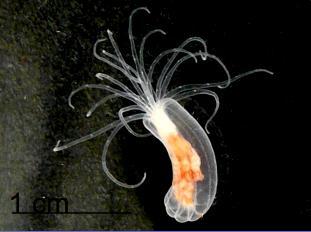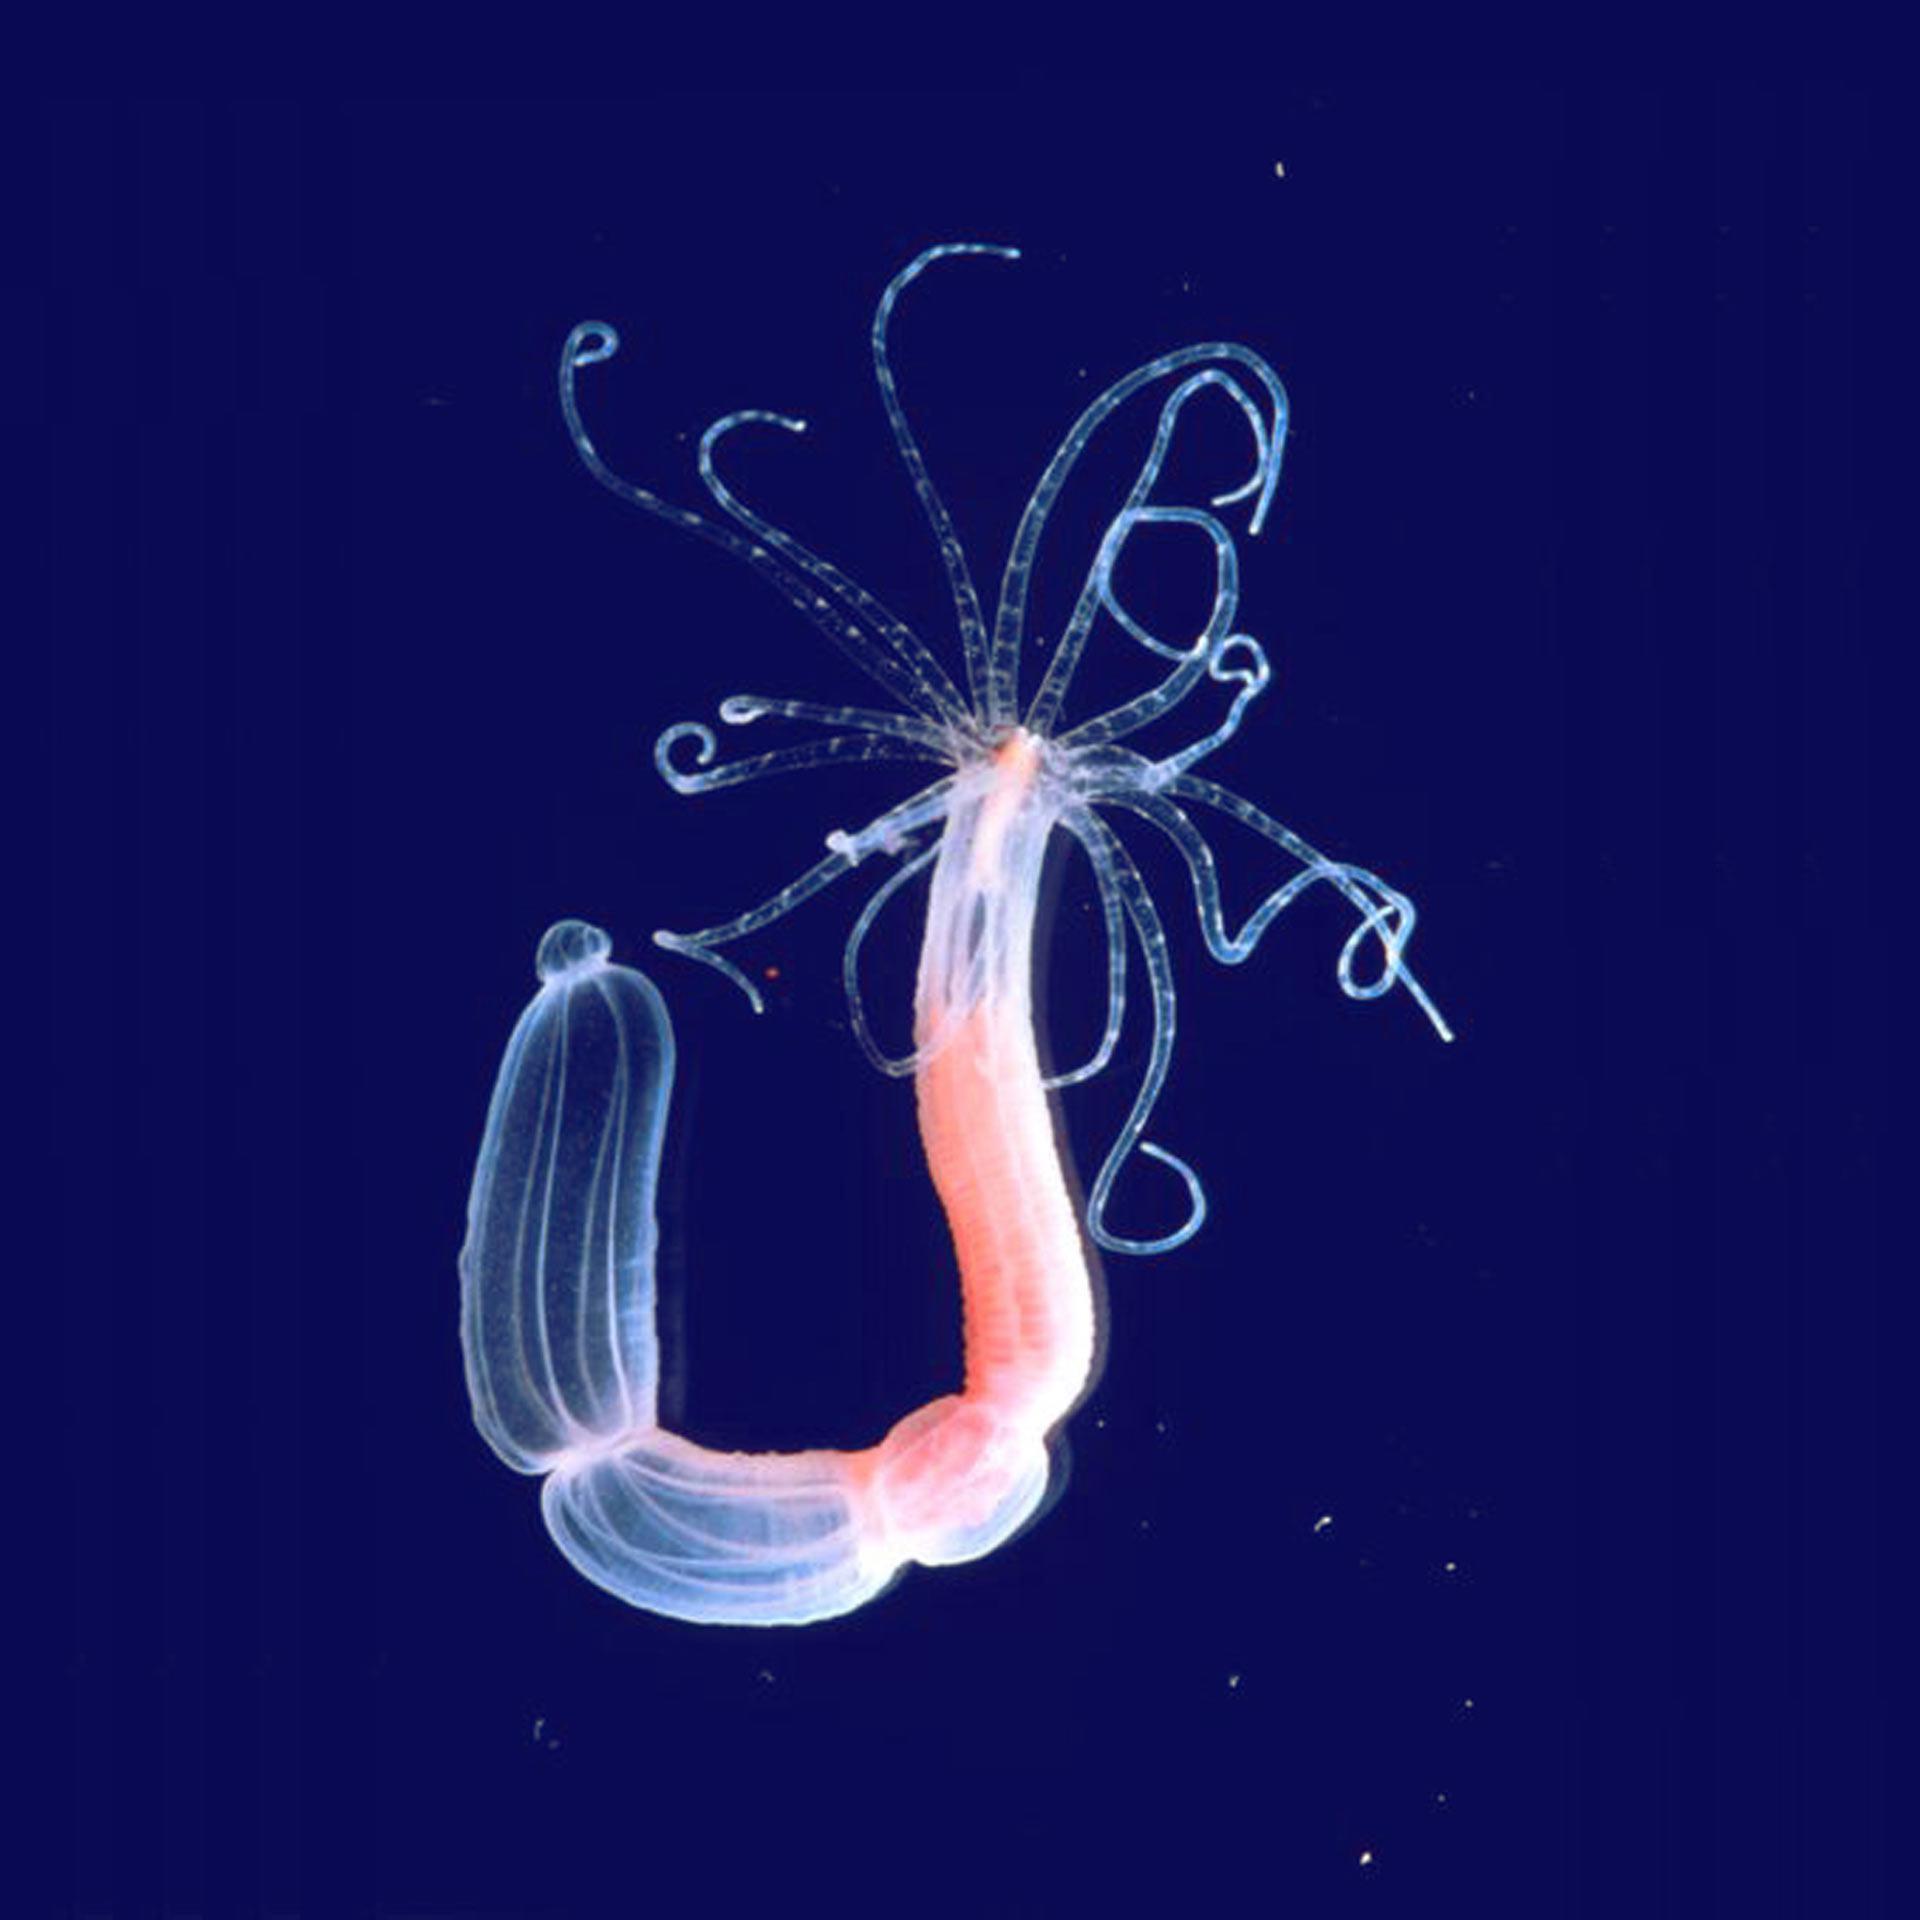The first image is the image on the left, the second image is the image on the right. Given the left and right images, does the statement "Each image shows only a single living organism." hold true? Answer yes or no. Yes. 